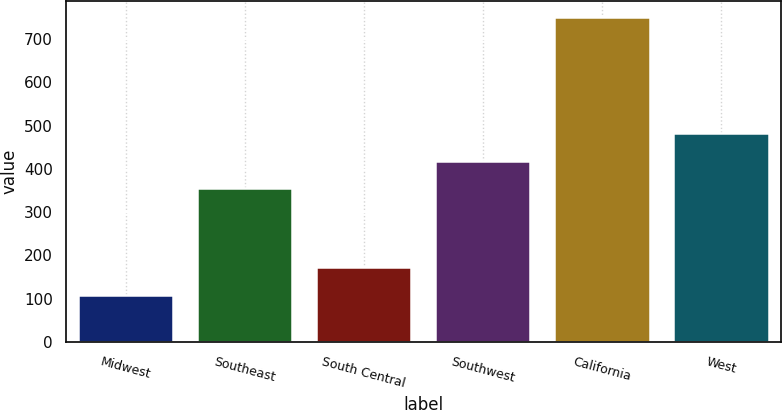Convert chart to OTSL. <chart><loc_0><loc_0><loc_500><loc_500><bar_chart><fcel>Midwest<fcel>Southeast<fcel>South Central<fcel>Southwest<fcel>California<fcel>West<nl><fcel>108.9<fcel>354.8<fcel>173.02<fcel>418.92<fcel>750.1<fcel>483.04<nl></chart> 